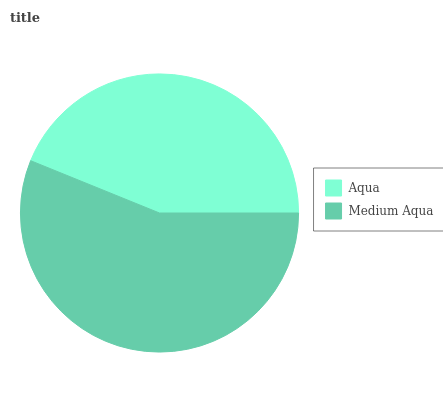Is Aqua the minimum?
Answer yes or no. Yes. Is Medium Aqua the maximum?
Answer yes or no. Yes. Is Medium Aqua the minimum?
Answer yes or no. No. Is Medium Aqua greater than Aqua?
Answer yes or no. Yes. Is Aqua less than Medium Aqua?
Answer yes or no. Yes. Is Aqua greater than Medium Aqua?
Answer yes or no. No. Is Medium Aqua less than Aqua?
Answer yes or no. No. Is Medium Aqua the high median?
Answer yes or no. Yes. Is Aqua the low median?
Answer yes or no. Yes. Is Aqua the high median?
Answer yes or no. No. Is Medium Aqua the low median?
Answer yes or no. No. 